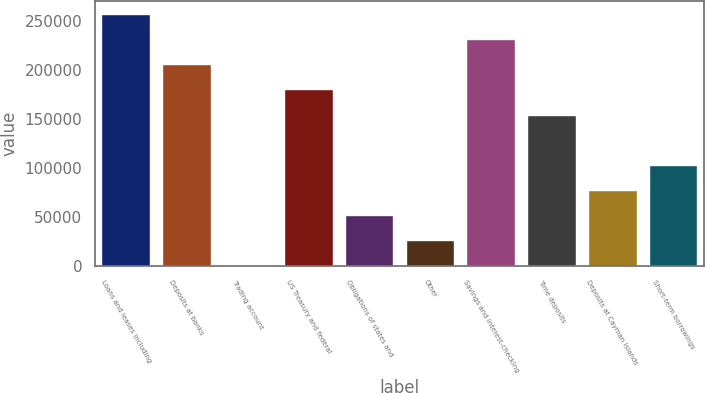Convert chart. <chart><loc_0><loc_0><loc_500><loc_500><bar_chart><fcel>Loans and leases including<fcel>Deposits at banks<fcel>Trading account<fcel>US Treasury and federal<fcel>Obligations of states and<fcel>Other<fcel>Savings and interest-checking<fcel>Time deposits<fcel>Deposits at Cayman Islands<fcel>Short-term borrowings<nl><fcel>257630<fcel>206106<fcel>8<fcel>180343<fcel>51532.4<fcel>25770.2<fcel>231868<fcel>154581<fcel>77294.6<fcel>103057<nl></chart> 